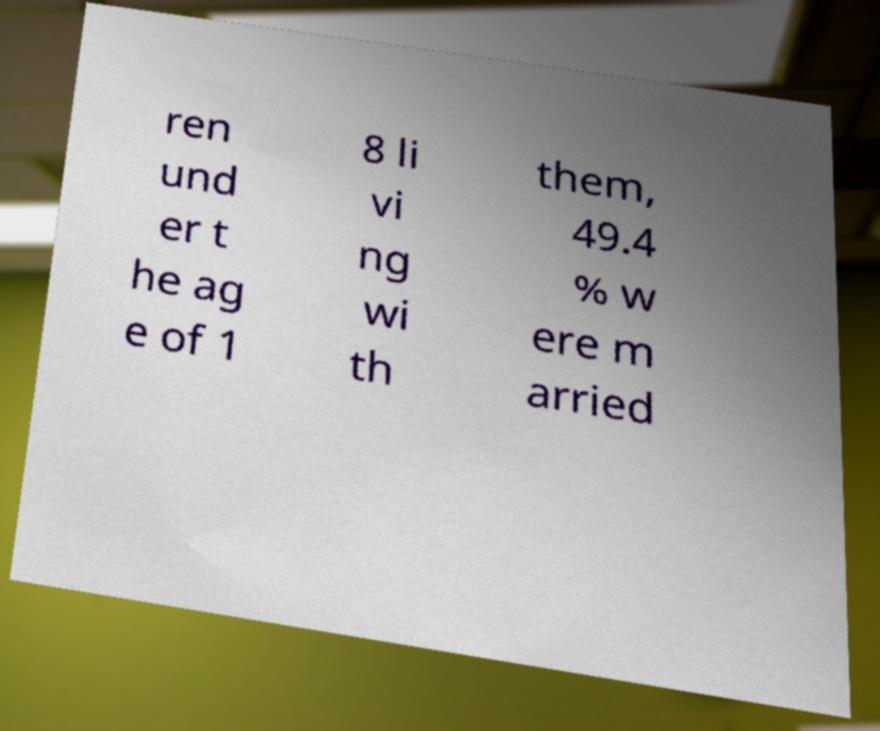Can you accurately transcribe the text from the provided image for me? ren und er t he ag e of 1 8 li vi ng wi th them, 49.4 % w ere m arried 